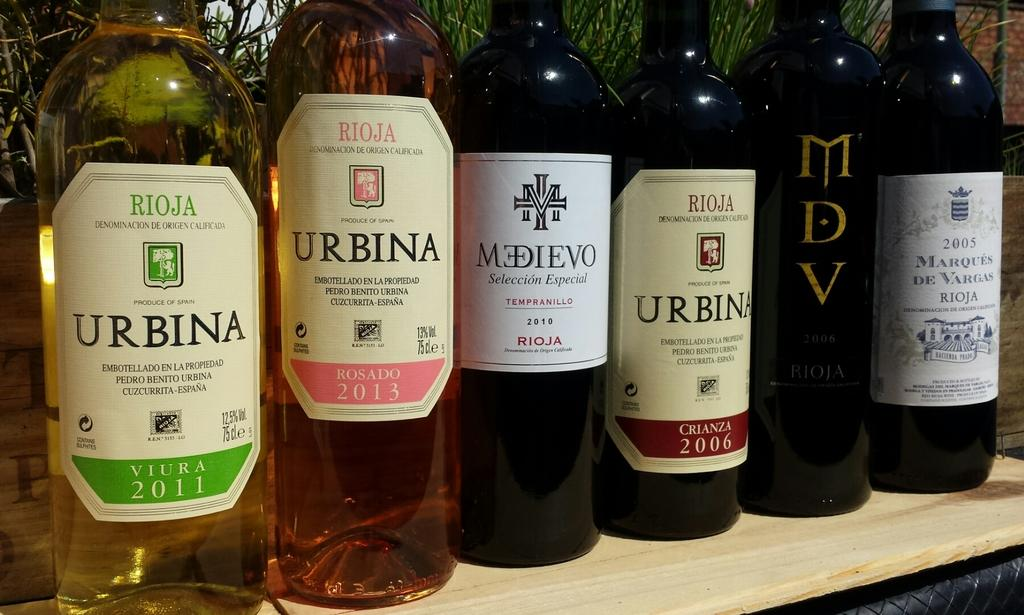Provide a one-sentence caption for the provided image. Six bottles of wine of which three are Urbina. 